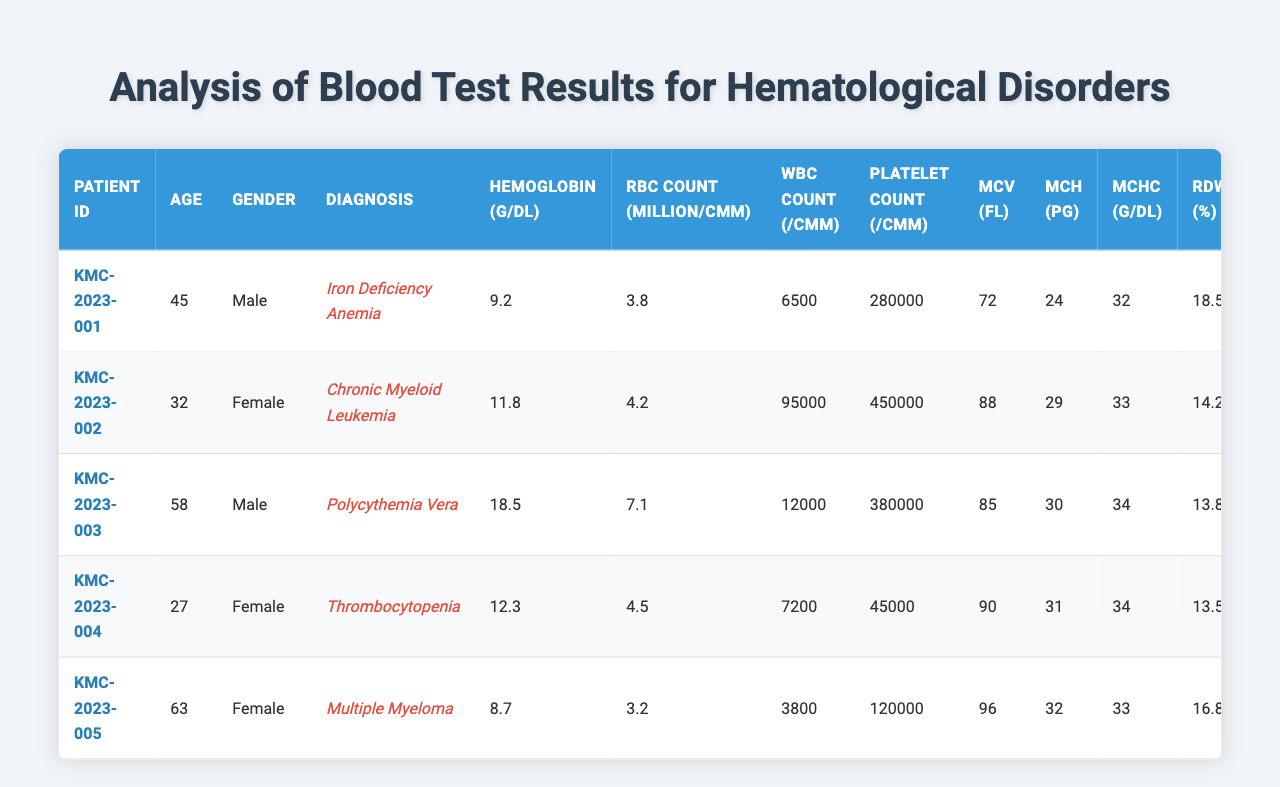What is the hemoglobin level of patient KMC-2023-001? From the table, the hemoglobin level for patient KMC-2023-001 is listed directly under the hemoglobin (g/dL) column. Specifically, it shows a hemoglobin level of 9.2 g/dL.
Answer: 9.2 g/dL Which patient has the highest platelet count? By examining the platelet count column, the highest value belongs to patient KMC-2023-002, which is 450,000 /cmm.
Answer: KMC-2023-002 What is the average age of all the patients? First, we sum the ages of all patients: 45 + 32 + 58 + 27 + 63 = 225. There are 5 patients, so the average age is 225 / 5 = 45.
Answer: 45 Is there a patient with both elevated WBC count and low hemoglobin level? We check the patient details: KMC-2023-002 has a WBC count of 95,000 /cmm (elevated) and a hemoglobin level of 11.8 g/dL (not low). KMC-2023-003 has a WBC count of 12,000 and hemoglobin of 18.5 g/dL (not low). KMC-2023-004 has a WBC count of 7,200 and a hemoglobin of 12.3 g/dL (not low). Thus, no patient meets both conditions.
Answer: No What is the difference in neutrophils percentage between the youngest and oldest patients? The youngest patient (KMC-2023-004) has a neutrophils percentage of 58, while the oldest patient (KMC-2023-005) has 45. The difference is 58 - 45 = 13.
Answer: 13 Which diagnosis has the highest serum ferritin level, and what is that level? We compare serum ferritin levels across the table. The highest serum ferritin level is found in patient KMC-2023-005 with a level of 750 ng/mL, and their diagnosis is Multiple Myeloma.
Answer: Multiple Myeloma, 750 ng/mL Are all female patients diagnosed with hematological disorders older than 30? Referring to the data, KMC-2023-002 (32 years old) and KMC-2023-004 (27 years old) are both females and below 30, indicating not all female patients meet this condition.
Answer: No What is the serum iron level of the patient diagnosed with Iron Deficiency Anemia? Checking the table, patient KMC-2023-001 has been diagnosed with Iron Deficiency Anemia, and their serum iron level is 25 mcg/dL.
Answer: 25 mcg/dL Which patient has a reticulocyte count above 2% and what is that count? Searching through the reticulocyte count column, KMC-2023-003 has a reticulocyte count of 3.8%, which is above 2%.
Answer: KMC-2023-003, 3.8% Calculate the average MCV of all patients. Adding the MCV values: 72 + 88 + 85 + 90 + 96 = 431. Thus, the average MCV is 431 / 5 = 86.2.
Answer: 86.2 Is there any patient diagnosed with Thrombocytopenia who has a low MCV? Patient KMC-2023-004 is diagnosed with Thrombocytopenia and has an MCV of 90 fL. Since 90 is not low, there is no patient matching this specific criteria.
Answer: No 